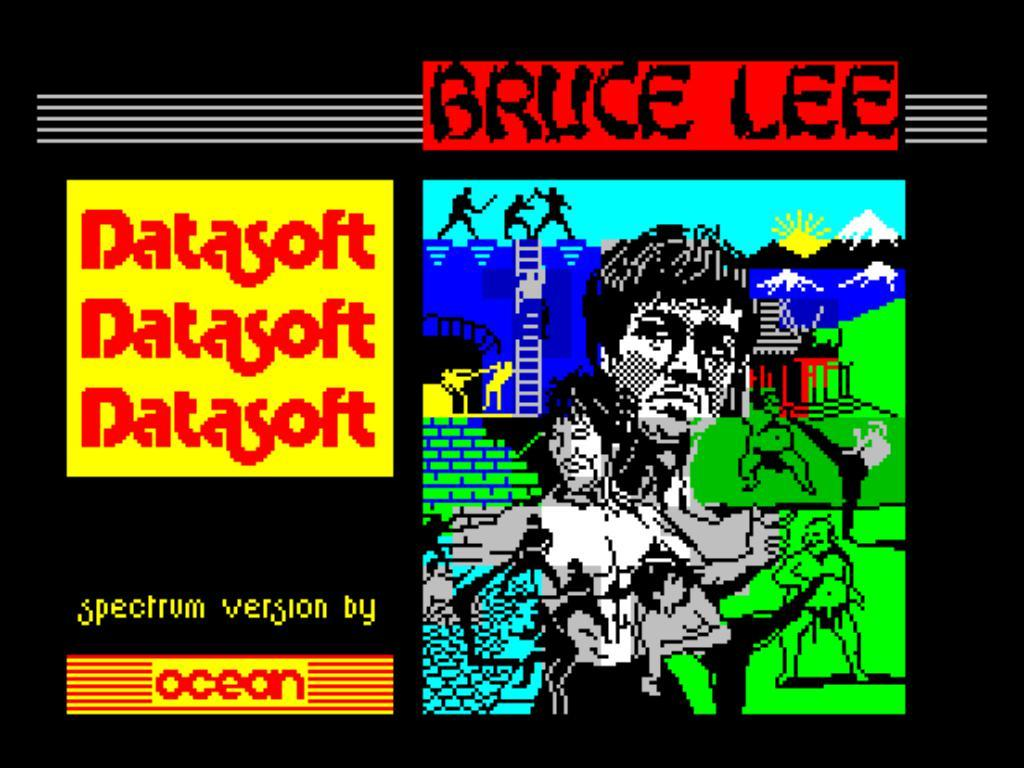<image>
Present a compact description of the photo's key features. A cartoon drawing of Bruce Lee by Datasoft. 